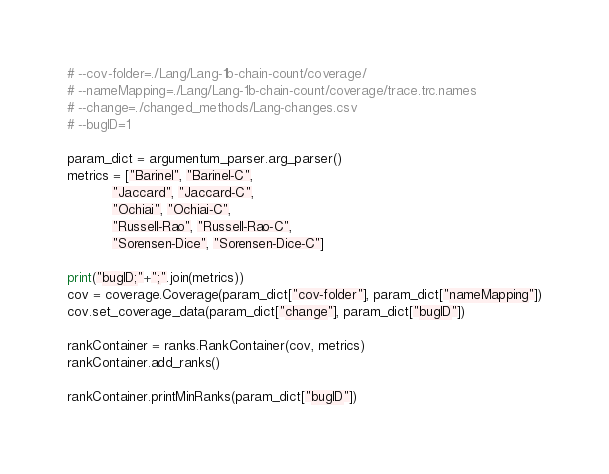Convert code to text. <code><loc_0><loc_0><loc_500><loc_500><_Python_># --cov-folder=./Lang/Lang-1b-chain-count/coverage/
# --nameMapping=./Lang/Lang-1b-chain-count/coverage/trace.trc.names
# --change=./changed_methods/Lang-changes.csv
# --bugID=1

param_dict = argumentum_parser.arg_parser()
metrics = ["Barinel", "Barinel-C",
           "Jaccard", "Jaccard-C",
           "Ochiai", "Ochiai-C",
           "Russell-Rao", "Russell-Rao-C",
           "Sorensen-Dice", "Sorensen-Dice-C"]

print("bugID;"+";".join(metrics))
cov = coverage.Coverage(param_dict["cov-folder"], param_dict["nameMapping"])
cov.set_coverage_data(param_dict["change"], param_dict["bugID"])

rankContainer = ranks.RankContainer(cov, metrics)
rankContainer.add_ranks()

rankContainer.printMinRanks(param_dict["bugID"])
</code> 